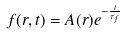Convert formula to latex. <formula><loc_0><loc_0><loc_500><loc_500>f ( r , t ) = A ( r ) e ^ { - { \frac { t } { { \tau } _ { f } } } }</formula> 